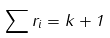Convert formula to latex. <formula><loc_0><loc_0><loc_500><loc_500>\sum r _ { i } = k + 1</formula> 